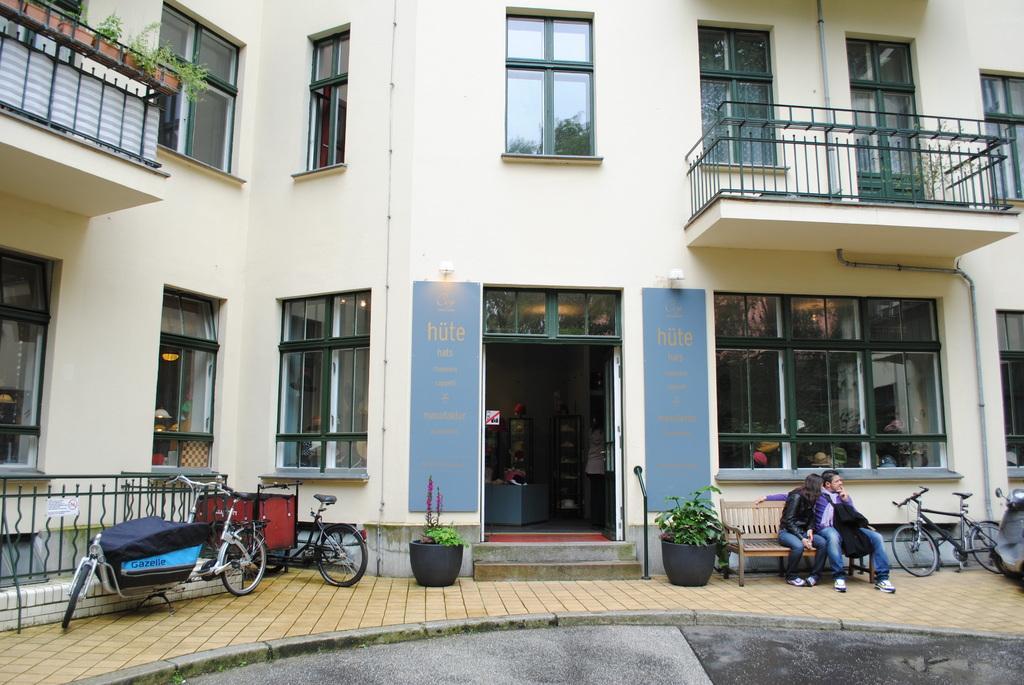Can you describe this image briefly? In this image in the front there are persons sitting on the bench and there are vehicles, bicycles, there are flower pots. In the background there is a building and on the building there are windows and inside the building there are persons visible and on the wall of the building there are boards with some text written on it. On the left side in front of the building there is a fence. 